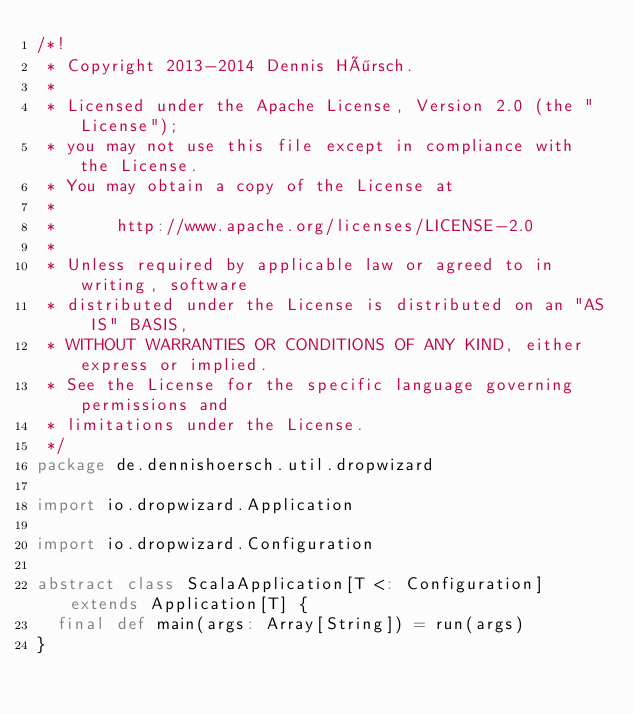Convert code to text. <code><loc_0><loc_0><loc_500><loc_500><_Scala_>/*!
 * Copyright 2013-2014 Dennis Hörsch.
 *
 * Licensed under the Apache License, Version 2.0 (the "License");
 * you may not use this file except in compliance with the License.
 * You may obtain a copy of the License at
 *
 *      http://www.apache.org/licenses/LICENSE-2.0
 *
 * Unless required by applicable law or agreed to in writing, software
 * distributed under the License is distributed on an "AS IS" BASIS,
 * WITHOUT WARRANTIES OR CONDITIONS OF ANY KIND, either express or implied.
 * See the License for the specific language governing permissions and
 * limitations under the License.
 */
package de.dennishoersch.util.dropwizard

import io.dropwizard.Application

import io.dropwizard.Configuration

abstract class ScalaApplication[T <: Configuration] extends Application[T] {
  final def main(args: Array[String]) = run(args)
}</code> 